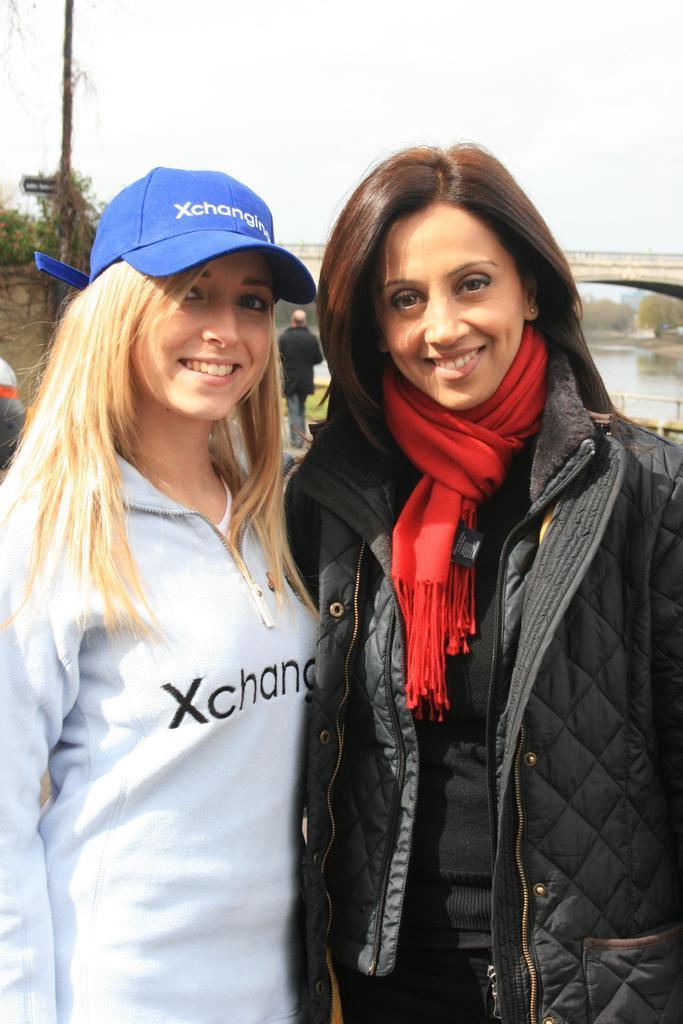Can you describe this image briefly? In this image in the foreground there are two people standing, and one person is wearing a jacket and scarf and one person is wearing a cap. And in the background there is a bridge, trees, pole and river. And at the top there is sky. 